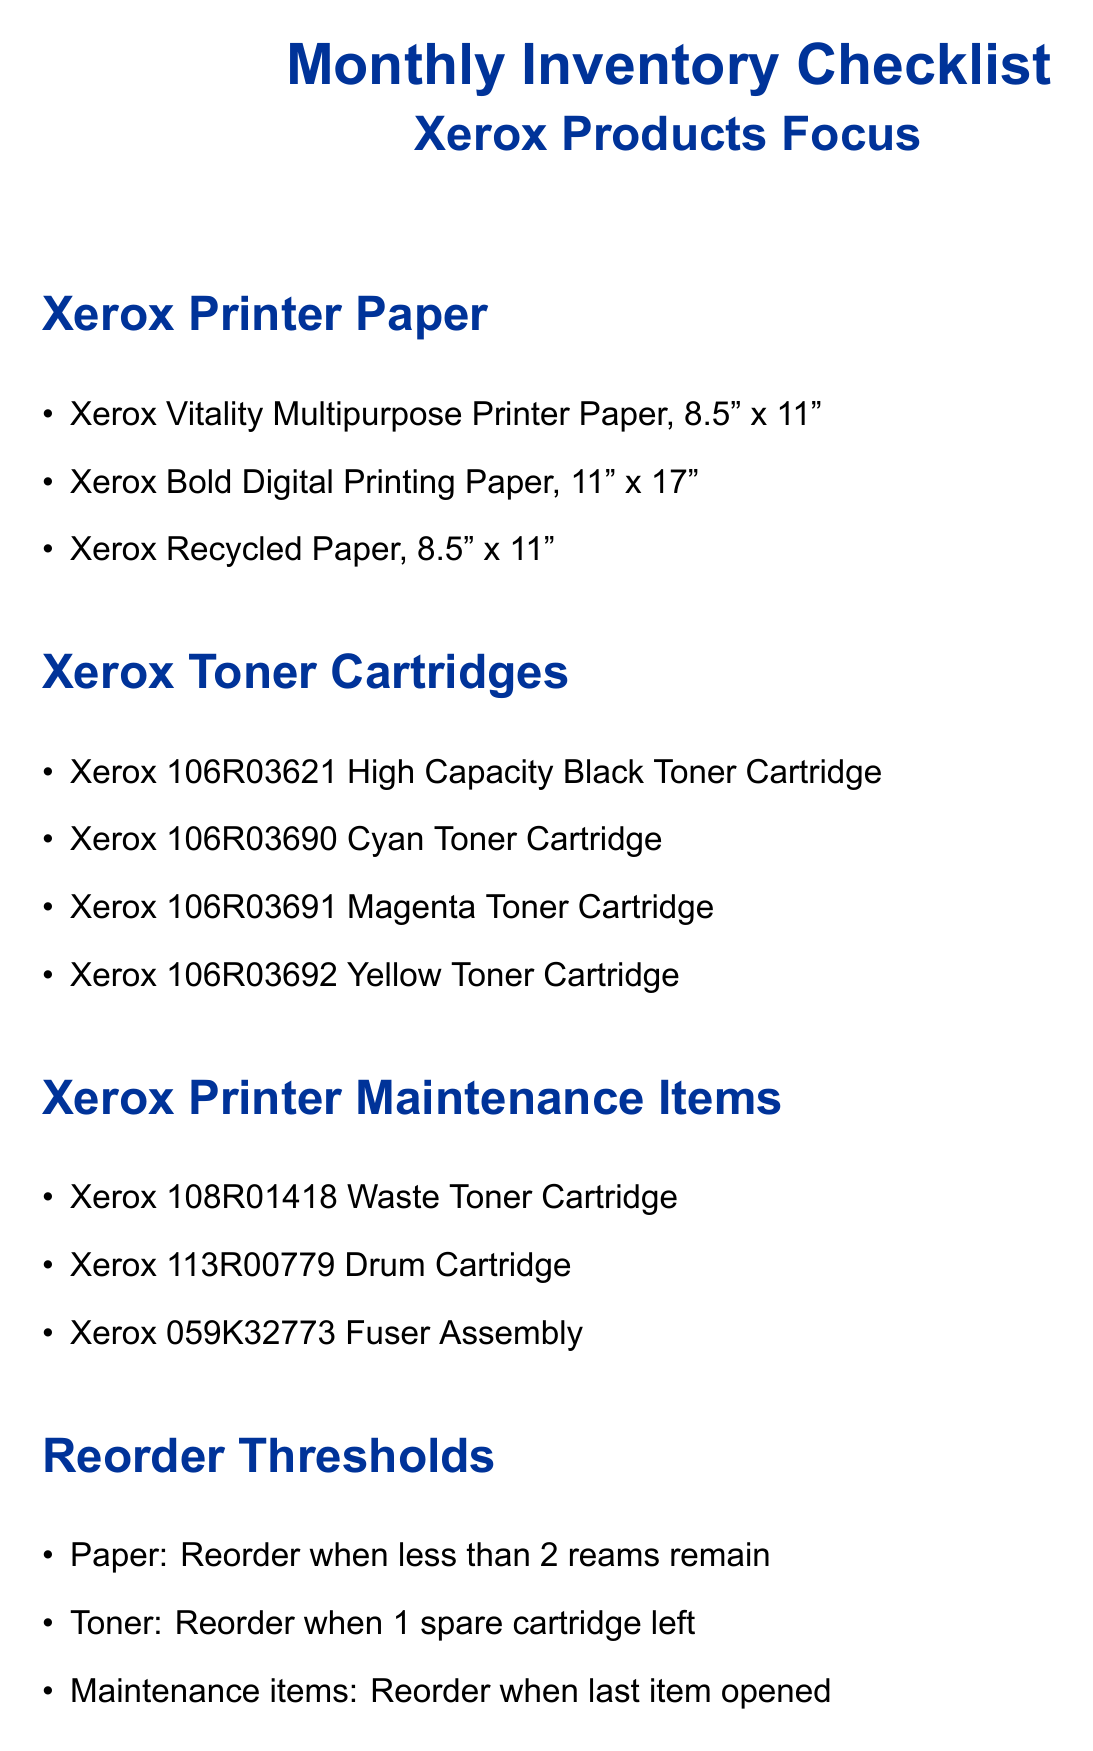What are the three types of Xerox printer paper listed? The document lists three types of printer paper under the section "Xerox Printer Paper."
Answer: Xerox Vitality Multipurpose Printer Paper, Xerox Bold Digital Printing Paper, Xerox Recycled Paper How many toner cartridges are listed? The section "Xerox Toner Cartridges" contains the names of four different toner cartridges.
Answer: Four What is the reorder threshold for maintenance items? The document states that maintenance items should be reordered when the last item is opened, which is detailed in the "Reorder Thresholds" section.
Answer: When last item opened Who is the account manager for Xerox? The document provides the account manager's name in the "Xerox Contact Information" section.
Answer: Sarah Johnson Which toner cartridge color is mentioned first? The order of the toner cartridges in the list dictates which color is mentioned first in the section titled "Xerox Toner Cartridges."
Answer: High Capacity Black What should you consider for frequently used items? The notes section suggests considering a specific action for frequently used items.
Answer: Scheduling automatic reorders What action is recommended when checking inventory for paper? The section on "Reorder Thresholds" specifies what to do for paper when a certain amount is left.
Answer: Reorder when less than 2 reams remain What email address is provided for the account manager? The "Xerox Contact Information" section includes a specific contact method for the account manager, providing a direct way to reach her.
Answer: sarah.johnson@xerox.com 